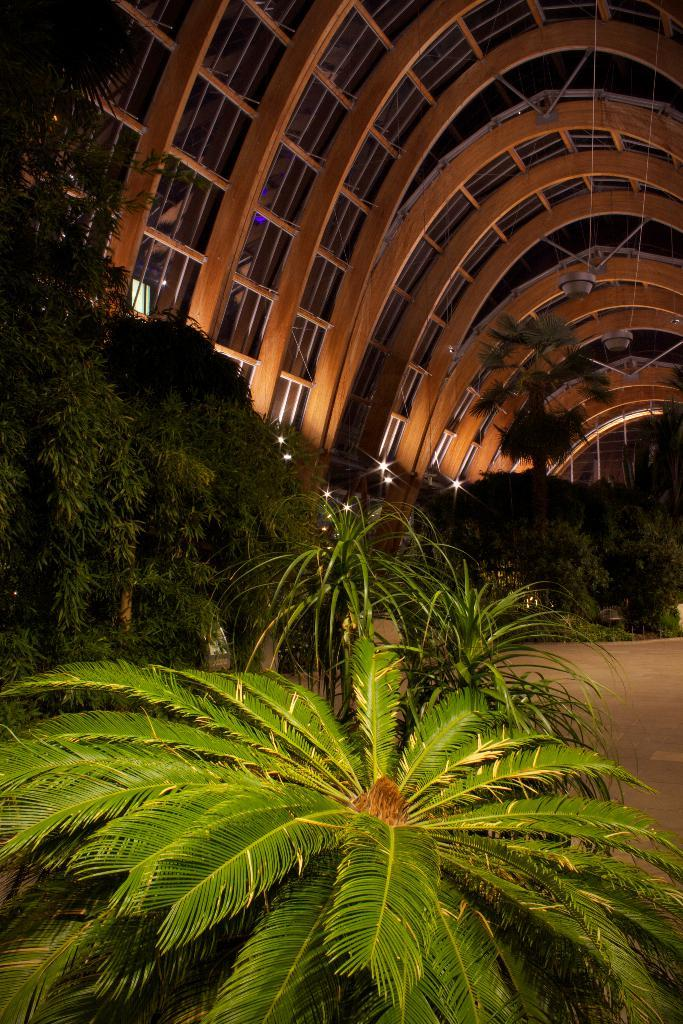What type of surface is visible in the image? There is ground visible in the image. What structure is present in the image? There is a roof in the image. What can be seen providing illumination in the image? There are lights in the image. What type of vegetation is present in the image? There are plants in the image. What else can be seen in the image besides the mentioned elements? There are some objects in the image. Can you tell me how many pets are visible in the image? There are no pets present in the image. What type of yarn is being used by the actor in the image? There is no actor or yarn present in the image. 